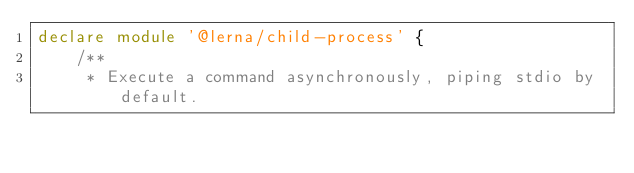<code> <loc_0><loc_0><loc_500><loc_500><_TypeScript_>declare module '@lerna/child-process' {
    /**
     * Execute a command asynchronously, piping stdio by default.</code> 